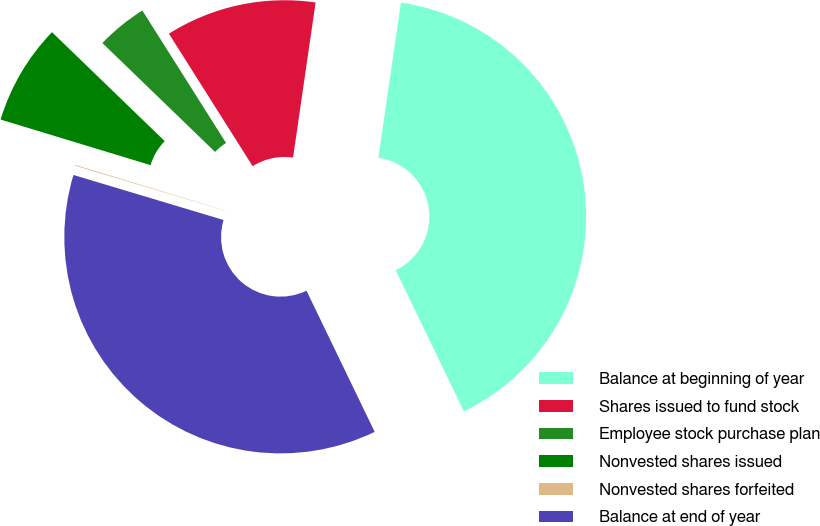Convert chart. <chart><loc_0><loc_0><loc_500><loc_500><pie_chart><fcel>Balance at beginning of year<fcel>Shares issued to fund stock<fcel>Employee stock purchase plan<fcel>Nonvested shares issued<fcel>Nonvested shares forfeited<fcel>Balance at end of year<nl><fcel>40.54%<fcel>11.27%<fcel>3.8%<fcel>7.53%<fcel>0.06%<fcel>36.8%<nl></chart> 